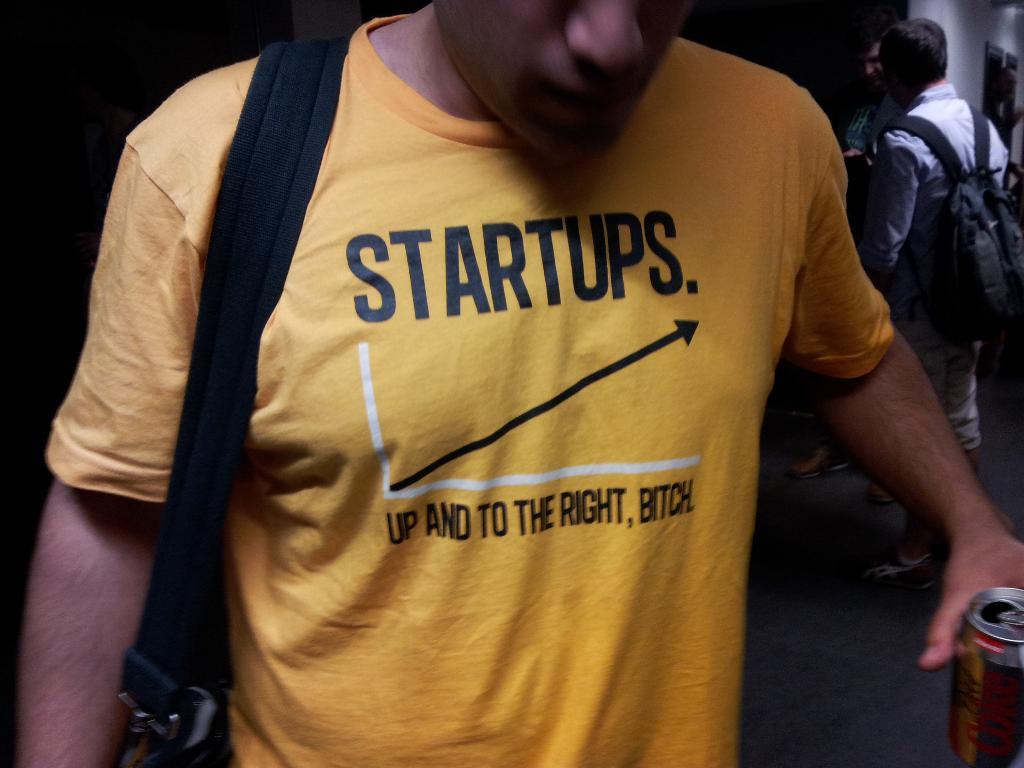What does the arrow show?
Offer a very short reply. Startups. 